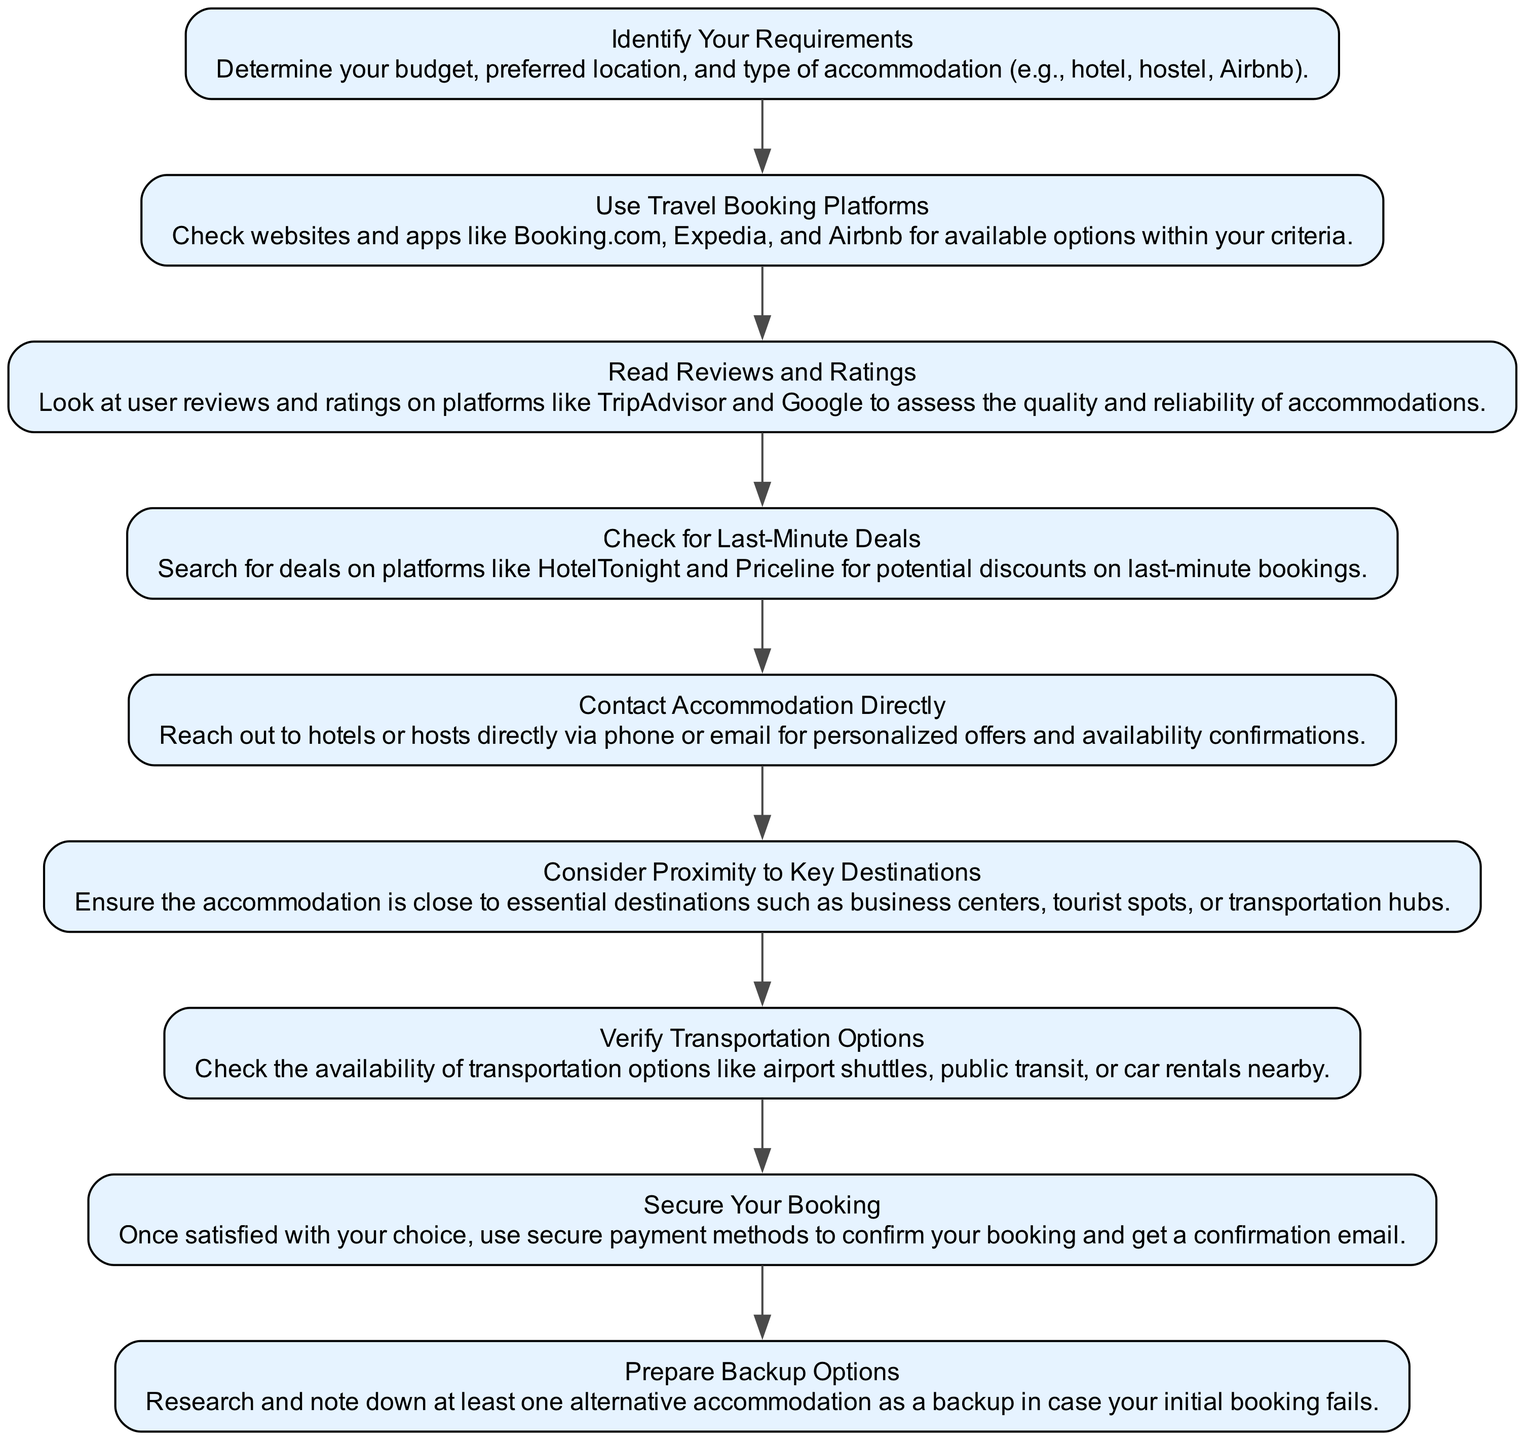What is the first step in the flowchart? The first step in the flowchart is "Identify Your Requirements," which begins the process of finding accommodations.
Answer: Identify Your Requirements How many steps are in the diagram? By counting each node in the flowchart from start to finish, you can see that there are a total of 9 steps depicted in the diagram.
Answer: 9 What step comes after "Read Reviews and Ratings"? The diagram shows that the step following "Read Reviews and Ratings" is "Check for Last-Minute Deals."
Answer: Check for Last-Minute Deals Which step focuses on budget considerations? The diagram clearly indicates that "Identify Your Requirements" is the step that emphasizes the importance of defining your budget.
Answer: Identify Your Requirements What is the last step in the process? In the flowchart, "Prepare Backup Options" is presented as the final step, indicating the completion of the accommodation-finding process.
Answer: Prepare Backup Options Explain the relationship between "Use Travel Booking Platforms" and "Secure Your Booking." "Use Travel Booking Platforms" precedes "Secure Your Booking," as it focuses on finding options before confirming the booking itself. This indicates a logical progression in the accommodation search.
Answer: Use Travel Booking Platforms precedes Secure Your Booking What is the significance of checking "Transportation Options"? The step "Verify Transportation Options" is essential because it assesses accessibility and convenience to and from the accommodation, impacting the overall travel experience.
Answer: Assess accessibility and convenience Which two steps mention direct communication? The steps "Contact Accommodation Directly" and "Secure Your Booking" both involve direct communication, indicating the need for interaction to confirm arrangements.
Answer: Contact Accommodation Directly and Secure Your Booking Which steps are related to deals and discounts? The steps "Check for Last-Minute Deals" and "Use Travel Booking Platforms" are related to discovering deals and discounts, focusing on cost-saving opportunities during the accommodation search.
Answer: Check for Last-Minute Deals and Use Travel Booking Platforms 